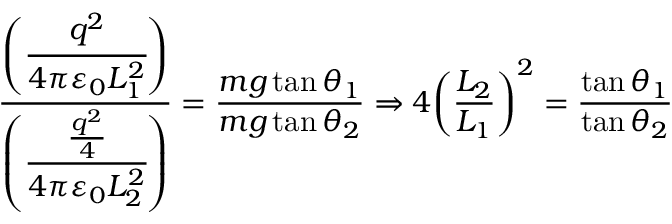<formula> <loc_0><loc_0><loc_500><loc_500>{ \frac { \left ( { \cfrac { q ^ { 2 } } { 4 \pi \varepsilon _ { 0 } L _ { 1 } ^ { 2 } } } \right ) } { \left ( { \cfrac { \frac { q ^ { 2 } } { 4 } } { 4 \pi \varepsilon _ { 0 } L _ { 2 } ^ { 2 } } } \right ) } } = { \frac { m g \tan \theta _ { 1 } } { m g \tan \theta _ { 2 } } } \Rightarrow 4 { \left ( { \frac { L _ { 2 } } { L _ { 1 } } } \right ) } ^ { 2 } = { \frac { \tan \theta _ { 1 } } { \tan \theta _ { 2 } } }</formula> 